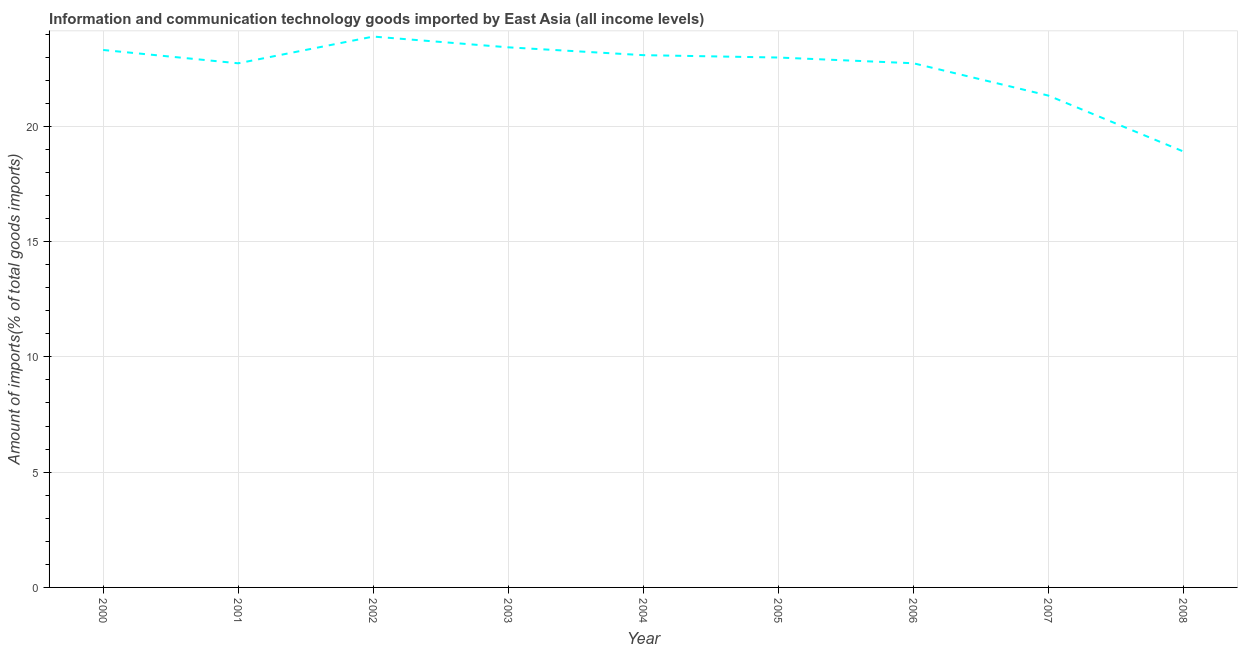What is the amount of ict goods imports in 2007?
Your response must be concise. 21.33. Across all years, what is the maximum amount of ict goods imports?
Provide a short and direct response. 23.89. Across all years, what is the minimum amount of ict goods imports?
Your response must be concise. 18.9. In which year was the amount of ict goods imports minimum?
Your answer should be very brief. 2008. What is the sum of the amount of ict goods imports?
Provide a short and direct response. 202.39. What is the difference between the amount of ict goods imports in 2004 and 2005?
Provide a short and direct response. 0.1. What is the average amount of ict goods imports per year?
Make the answer very short. 22.49. What is the median amount of ict goods imports?
Ensure brevity in your answer.  22.98. In how many years, is the amount of ict goods imports greater than 10 %?
Provide a succinct answer. 9. What is the ratio of the amount of ict goods imports in 2002 to that in 2003?
Your answer should be very brief. 1.02. What is the difference between the highest and the second highest amount of ict goods imports?
Your response must be concise. 0.47. Is the sum of the amount of ict goods imports in 2007 and 2008 greater than the maximum amount of ict goods imports across all years?
Offer a very short reply. Yes. What is the difference between the highest and the lowest amount of ict goods imports?
Offer a terse response. 4.99. In how many years, is the amount of ict goods imports greater than the average amount of ict goods imports taken over all years?
Provide a succinct answer. 7. How many lines are there?
Your response must be concise. 1. Does the graph contain grids?
Provide a succinct answer. Yes. What is the title of the graph?
Your answer should be very brief. Information and communication technology goods imported by East Asia (all income levels). What is the label or title of the X-axis?
Provide a short and direct response. Year. What is the label or title of the Y-axis?
Your answer should be very brief. Amount of imports(% of total goods imports). What is the Amount of imports(% of total goods imports) of 2000?
Make the answer very short. 23.31. What is the Amount of imports(% of total goods imports) of 2001?
Provide a succinct answer. 22.73. What is the Amount of imports(% of total goods imports) in 2002?
Make the answer very short. 23.89. What is the Amount of imports(% of total goods imports) in 2003?
Make the answer very short. 23.42. What is the Amount of imports(% of total goods imports) in 2004?
Offer a terse response. 23.09. What is the Amount of imports(% of total goods imports) in 2005?
Your answer should be very brief. 22.98. What is the Amount of imports(% of total goods imports) in 2006?
Your answer should be very brief. 22.73. What is the Amount of imports(% of total goods imports) in 2007?
Provide a succinct answer. 21.33. What is the Amount of imports(% of total goods imports) of 2008?
Your answer should be compact. 18.9. What is the difference between the Amount of imports(% of total goods imports) in 2000 and 2001?
Your response must be concise. 0.58. What is the difference between the Amount of imports(% of total goods imports) in 2000 and 2002?
Your response must be concise. -0.58. What is the difference between the Amount of imports(% of total goods imports) in 2000 and 2003?
Keep it short and to the point. -0.11. What is the difference between the Amount of imports(% of total goods imports) in 2000 and 2004?
Make the answer very short. 0.22. What is the difference between the Amount of imports(% of total goods imports) in 2000 and 2005?
Provide a short and direct response. 0.33. What is the difference between the Amount of imports(% of total goods imports) in 2000 and 2006?
Your response must be concise. 0.58. What is the difference between the Amount of imports(% of total goods imports) in 2000 and 2007?
Make the answer very short. 1.98. What is the difference between the Amount of imports(% of total goods imports) in 2000 and 2008?
Make the answer very short. 4.4. What is the difference between the Amount of imports(% of total goods imports) in 2001 and 2002?
Your response must be concise. -1.16. What is the difference between the Amount of imports(% of total goods imports) in 2001 and 2003?
Offer a terse response. -0.69. What is the difference between the Amount of imports(% of total goods imports) in 2001 and 2004?
Provide a succinct answer. -0.35. What is the difference between the Amount of imports(% of total goods imports) in 2001 and 2005?
Make the answer very short. -0.25. What is the difference between the Amount of imports(% of total goods imports) in 2001 and 2006?
Provide a succinct answer. -0. What is the difference between the Amount of imports(% of total goods imports) in 2001 and 2007?
Give a very brief answer. 1.4. What is the difference between the Amount of imports(% of total goods imports) in 2001 and 2008?
Give a very brief answer. 3.83. What is the difference between the Amount of imports(% of total goods imports) in 2002 and 2003?
Keep it short and to the point. 0.47. What is the difference between the Amount of imports(% of total goods imports) in 2002 and 2004?
Offer a very short reply. 0.81. What is the difference between the Amount of imports(% of total goods imports) in 2002 and 2005?
Give a very brief answer. 0.91. What is the difference between the Amount of imports(% of total goods imports) in 2002 and 2006?
Keep it short and to the point. 1.16. What is the difference between the Amount of imports(% of total goods imports) in 2002 and 2007?
Your response must be concise. 2.56. What is the difference between the Amount of imports(% of total goods imports) in 2002 and 2008?
Provide a succinct answer. 4.99. What is the difference between the Amount of imports(% of total goods imports) in 2003 and 2004?
Keep it short and to the point. 0.34. What is the difference between the Amount of imports(% of total goods imports) in 2003 and 2005?
Provide a short and direct response. 0.44. What is the difference between the Amount of imports(% of total goods imports) in 2003 and 2006?
Offer a terse response. 0.69. What is the difference between the Amount of imports(% of total goods imports) in 2003 and 2007?
Ensure brevity in your answer.  2.09. What is the difference between the Amount of imports(% of total goods imports) in 2003 and 2008?
Keep it short and to the point. 4.52. What is the difference between the Amount of imports(% of total goods imports) in 2004 and 2005?
Offer a very short reply. 0.1. What is the difference between the Amount of imports(% of total goods imports) in 2004 and 2006?
Your response must be concise. 0.35. What is the difference between the Amount of imports(% of total goods imports) in 2004 and 2007?
Your response must be concise. 1.75. What is the difference between the Amount of imports(% of total goods imports) in 2004 and 2008?
Give a very brief answer. 4.18. What is the difference between the Amount of imports(% of total goods imports) in 2005 and 2006?
Provide a succinct answer. 0.25. What is the difference between the Amount of imports(% of total goods imports) in 2005 and 2007?
Keep it short and to the point. 1.65. What is the difference between the Amount of imports(% of total goods imports) in 2005 and 2008?
Offer a very short reply. 4.08. What is the difference between the Amount of imports(% of total goods imports) in 2006 and 2007?
Your response must be concise. 1.4. What is the difference between the Amount of imports(% of total goods imports) in 2006 and 2008?
Offer a very short reply. 3.83. What is the difference between the Amount of imports(% of total goods imports) in 2007 and 2008?
Keep it short and to the point. 2.43. What is the ratio of the Amount of imports(% of total goods imports) in 2000 to that in 2001?
Ensure brevity in your answer.  1.02. What is the ratio of the Amount of imports(% of total goods imports) in 2000 to that in 2002?
Make the answer very short. 0.98. What is the ratio of the Amount of imports(% of total goods imports) in 2000 to that in 2003?
Give a very brief answer. 0.99. What is the ratio of the Amount of imports(% of total goods imports) in 2000 to that in 2006?
Your answer should be compact. 1.02. What is the ratio of the Amount of imports(% of total goods imports) in 2000 to that in 2007?
Offer a very short reply. 1.09. What is the ratio of the Amount of imports(% of total goods imports) in 2000 to that in 2008?
Offer a very short reply. 1.23. What is the ratio of the Amount of imports(% of total goods imports) in 2001 to that in 2002?
Offer a terse response. 0.95. What is the ratio of the Amount of imports(% of total goods imports) in 2001 to that in 2003?
Your answer should be very brief. 0.97. What is the ratio of the Amount of imports(% of total goods imports) in 2001 to that in 2004?
Your answer should be very brief. 0.98. What is the ratio of the Amount of imports(% of total goods imports) in 2001 to that in 2006?
Make the answer very short. 1. What is the ratio of the Amount of imports(% of total goods imports) in 2001 to that in 2007?
Provide a succinct answer. 1.07. What is the ratio of the Amount of imports(% of total goods imports) in 2001 to that in 2008?
Give a very brief answer. 1.2. What is the ratio of the Amount of imports(% of total goods imports) in 2002 to that in 2003?
Provide a succinct answer. 1.02. What is the ratio of the Amount of imports(% of total goods imports) in 2002 to that in 2004?
Give a very brief answer. 1.03. What is the ratio of the Amount of imports(% of total goods imports) in 2002 to that in 2006?
Make the answer very short. 1.05. What is the ratio of the Amount of imports(% of total goods imports) in 2002 to that in 2007?
Give a very brief answer. 1.12. What is the ratio of the Amount of imports(% of total goods imports) in 2002 to that in 2008?
Give a very brief answer. 1.26. What is the ratio of the Amount of imports(% of total goods imports) in 2003 to that in 2006?
Your response must be concise. 1.03. What is the ratio of the Amount of imports(% of total goods imports) in 2003 to that in 2007?
Your answer should be compact. 1.1. What is the ratio of the Amount of imports(% of total goods imports) in 2003 to that in 2008?
Provide a short and direct response. 1.24. What is the ratio of the Amount of imports(% of total goods imports) in 2004 to that in 2006?
Make the answer very short. 1.01. What is the ratio of the Amount of imports(% of total goods imports) in 2004 to that in 2007?
Your response must be concise. 1.08. What is the ratio of the Amount of imports(% of total goods imports) in 2004 to that in 2008?
Your answer should be compact. 1.22. What is the ratio of the Amount of imports(% of total goods imports) in 2005 to that in 2007?
Keep it short and to the point. 1.08. What is the ratio of the Amount of imports(% of total goods imports) in 2005 to that in 2008?
Offer a terse response. 1.22. What is the ratio of the Amount of imports(% of total goods imports) in 2006 to that in 2007?
Provide a succinct answer. 1.07. What is the ratio of the Amount of imports(% of total goods imports) in 2006 to that in 2008?
Give a very brief answer. 1.2. What is the ratio of the Amount of imports(% of total goods imports) in 2007 to that in 2008?
Your answer should be compact. 1.13. 